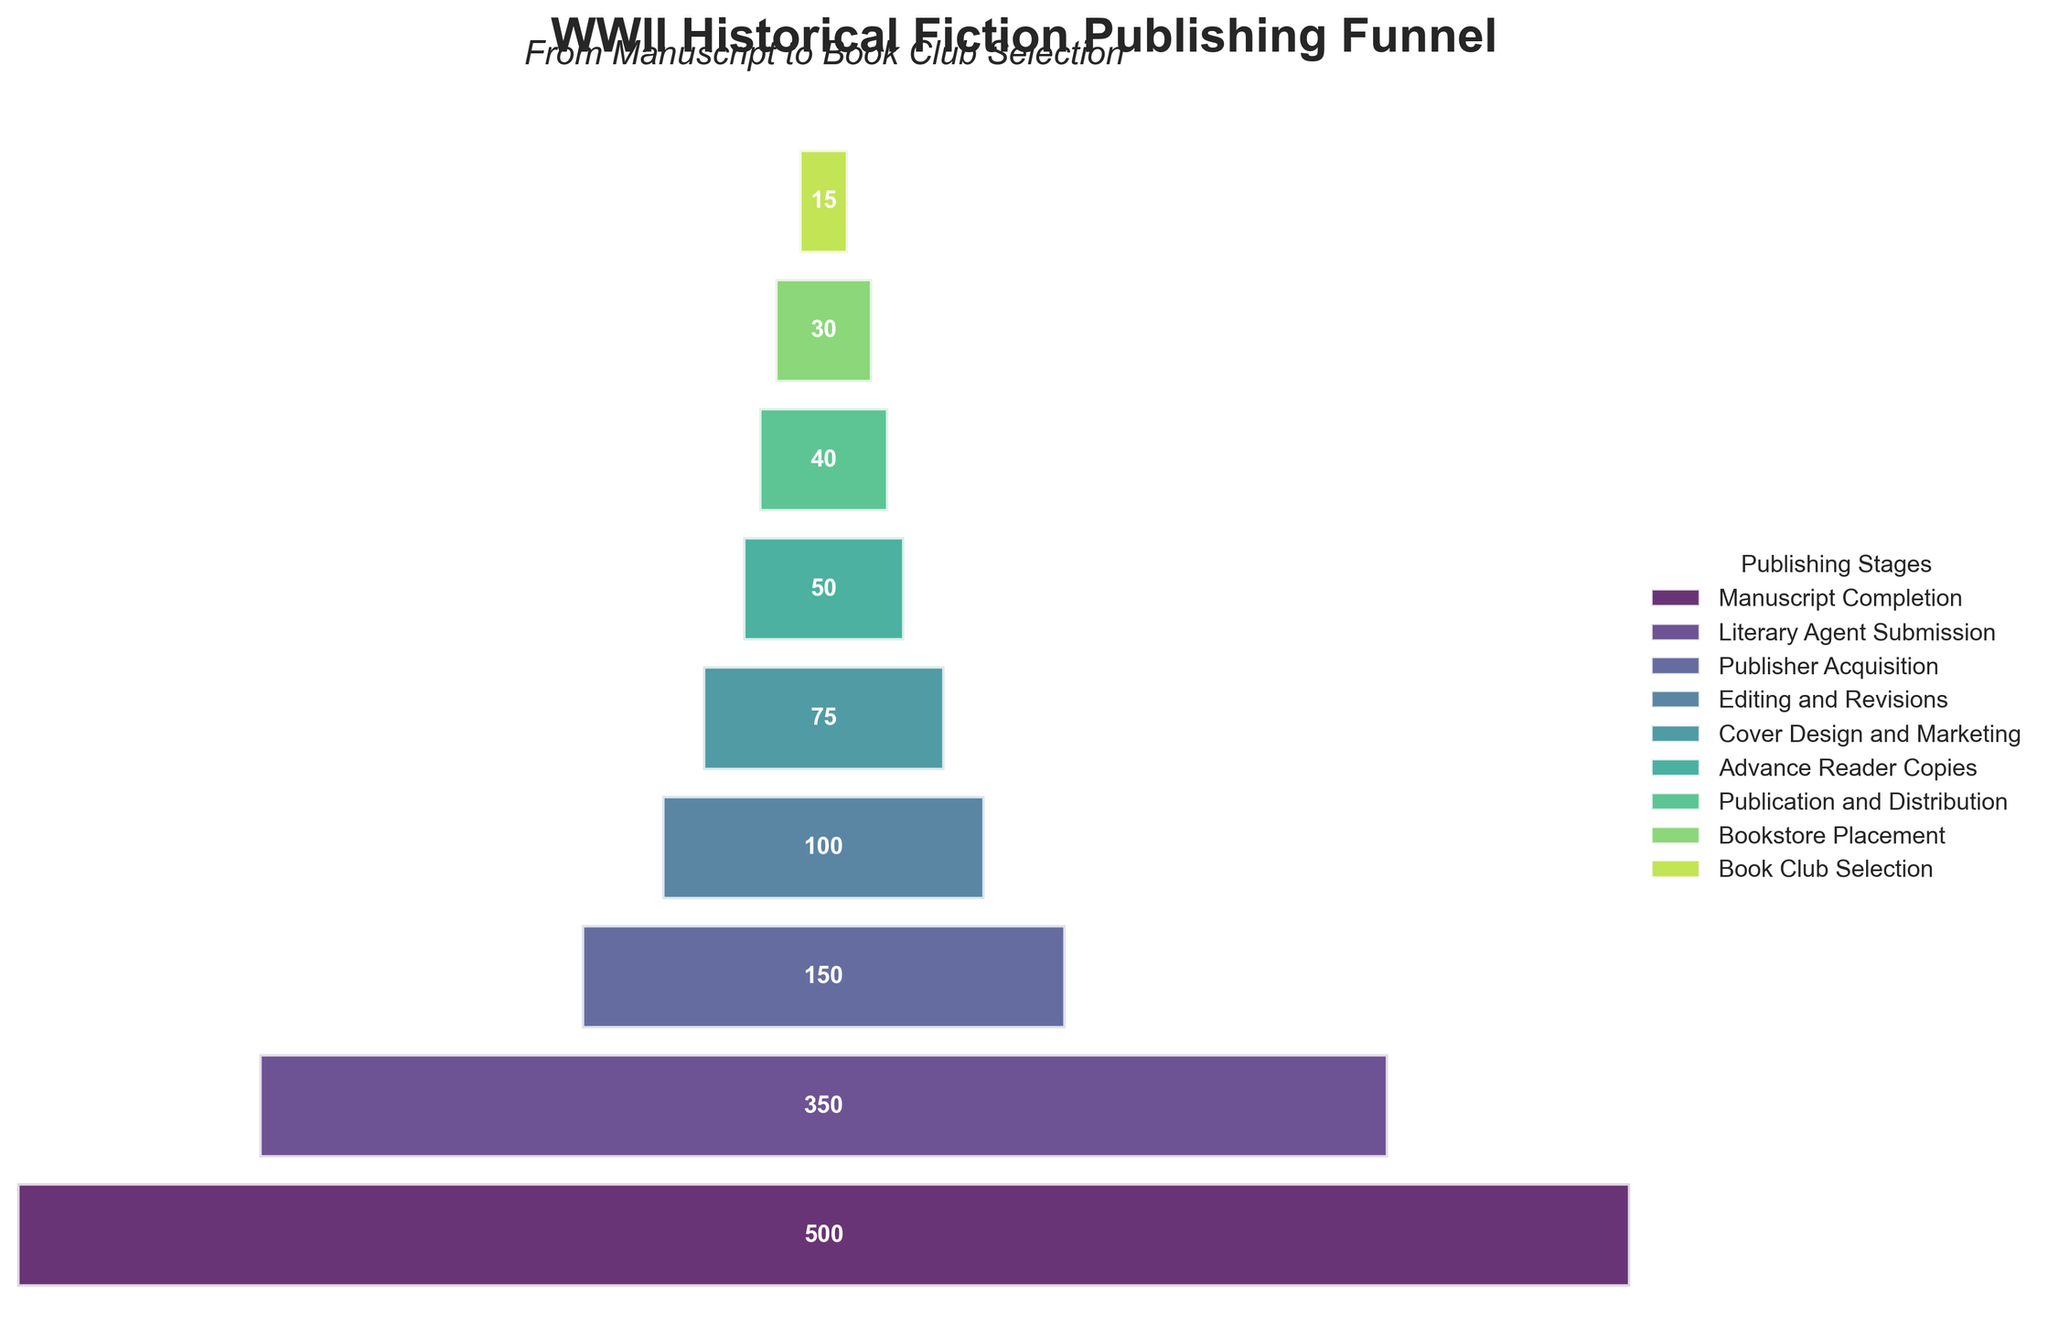What is the title of the figure? The title of the figure is located at the top and gives a summary of what the chart represents.
Answer: WWII Historical Fiction Publishing Funnel How many books reach the Publisher Acquisition stage? The figure displays the number of books at each stage on the funnel chart. The number for Publisher Acquisition can be read directly from the chart.
Answer: 150 Which stage has the highest number of books? By examining the lengths of the horizontal bars, the widest bar corresponds to the highest number of books.
Answer: Manuscript Completion How many books are lost between the Literary Agent Submission and the Publisher Acquisition stages? Subtract the number of books at Publisher Acquisition (150) from the number at Literary Agent Submission (350): 350 - 150 = 200
Answer: 200 Which two stages have the smallest drop in the number of books between them? Analyze the differences in the number of books between successive stages and identify the smallest difference. The stages with the smallest difference are Editing and Revisions (100) and Cover Design and Marketing (75): 100 - 75 = 25
Answer: Editing and Revisions to Cover Design and Marketing What is the ratio of books that reach the Book Club Selection stage to those that start at Manuscript Completion? Divide the number of books at Book Club Selection (15) by the number at Manuscript Completion (500): 15 / 500 = 0.03
Answer: 0.03 How does the number of books change from Advance Reader Copies to Bookstore Placement? Subtract the number of books at Bookstore Placement (30) from the number at Advance Reader Copies (50): 50 - 30 = 20
Answer: Decrease by 20 What percentage of books make it from Manuscript Completion to Publication and Distribution? Divide the number of books at Publication and Distribution (40) by the number at Manuscript Completion (500) and multiply by 100: (40 / 500) * 100 = 8%
Answer: 8% What is the difference in the number of books between Cover Design and Marketing and the next stage? Subtract the number of books at Advance Reader Copies (50) from the number at Cover Design and Marketing (75): 75 - 50 = 25
Answer: 25 What’s the total number of books that do not reach the final stage (Book Club Selection)? Subtract the number of books at Book Club Selection (15) from the number at Manuscript Completion (500): 500 - 15 = 485
Answer: 485 